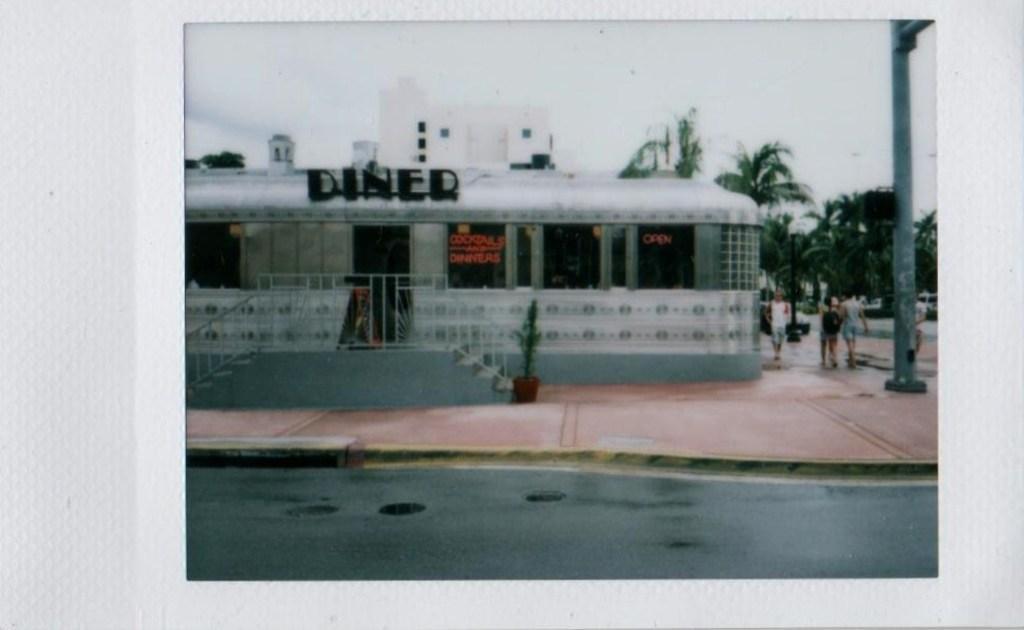Please provide a concise description of this image. In this image we can see the photo of a few buildings, trees, a pole and few people are walking on the pavement. 